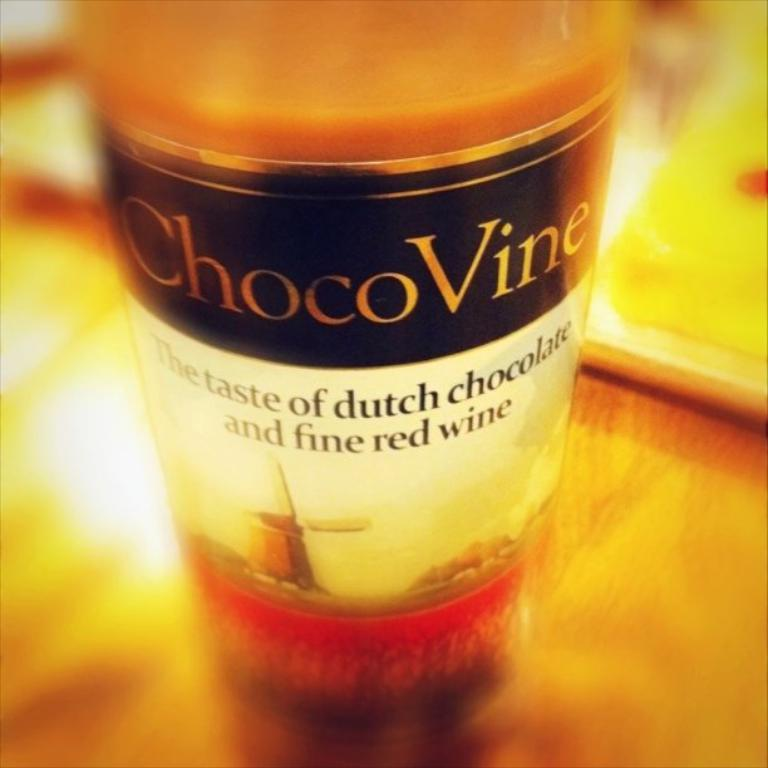Provide a one-sentence caption for the provided image. A bottle of ChocoVine is displayed with the words "The Taste of dutch chocolate and fine red wine" on the label. 